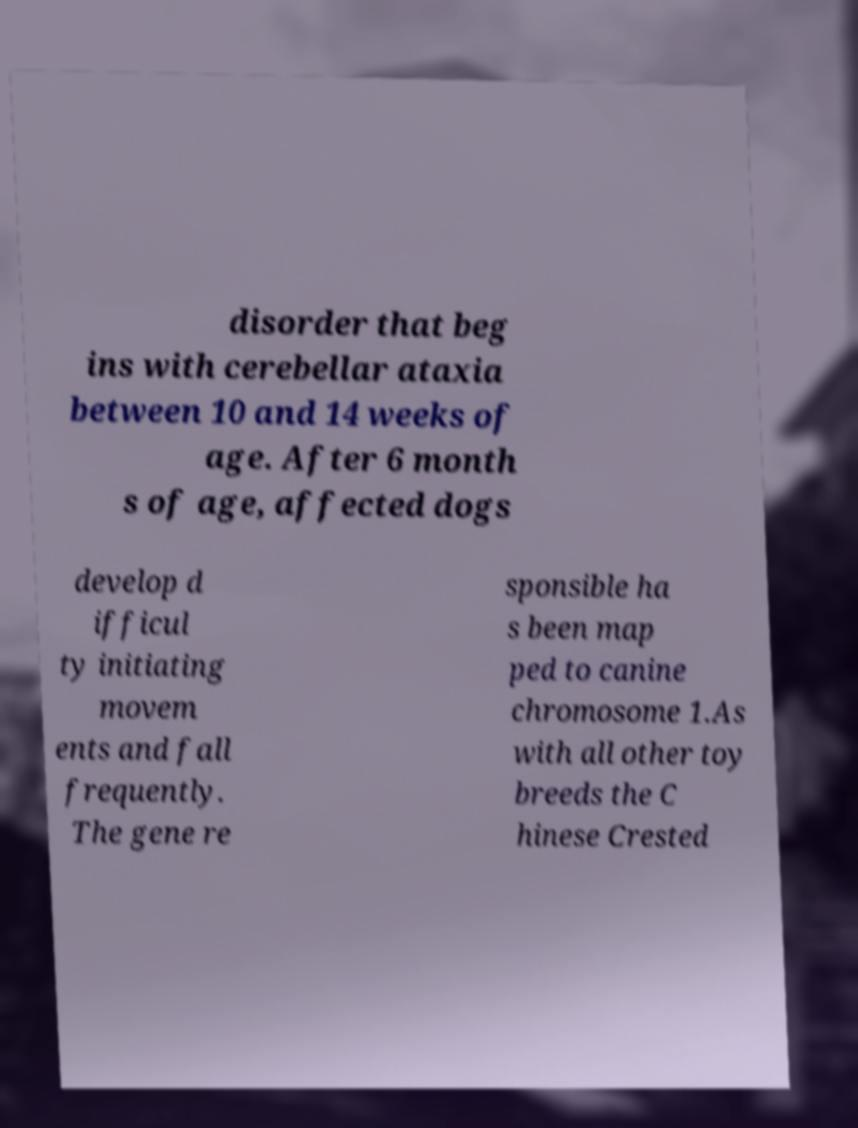Could you assist in decoding the text presented in this image and type it out clearly? disorder that beg ins with cerebellar ataxia between 10 and 14 weeks of age. After 6 month s of age, affected dogs develop d ifficul ty initiating movem ents and fall frequently. The gene re sponsible ha s been map ped to canine chromosome 1.As with all other toy breeds the C hinese Crested 